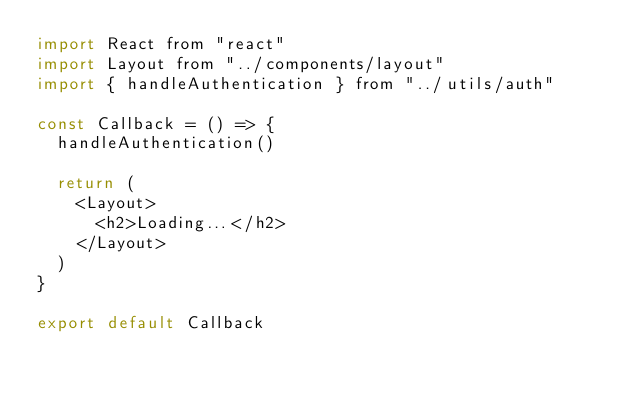Convert code to text. <code><loc_0><loc_0><loc_500><loc_500><_JavaScript_>import React from "react"
import Layout from "../components/layout"
import { handleAuthentication } from "../utils/auth"

const Callback = () => {
  handleAuthentication()

  return (
    <Layout>
      <h2>Loading...</h2>
    </Layout>
  )
}

export default Callback
</code> 